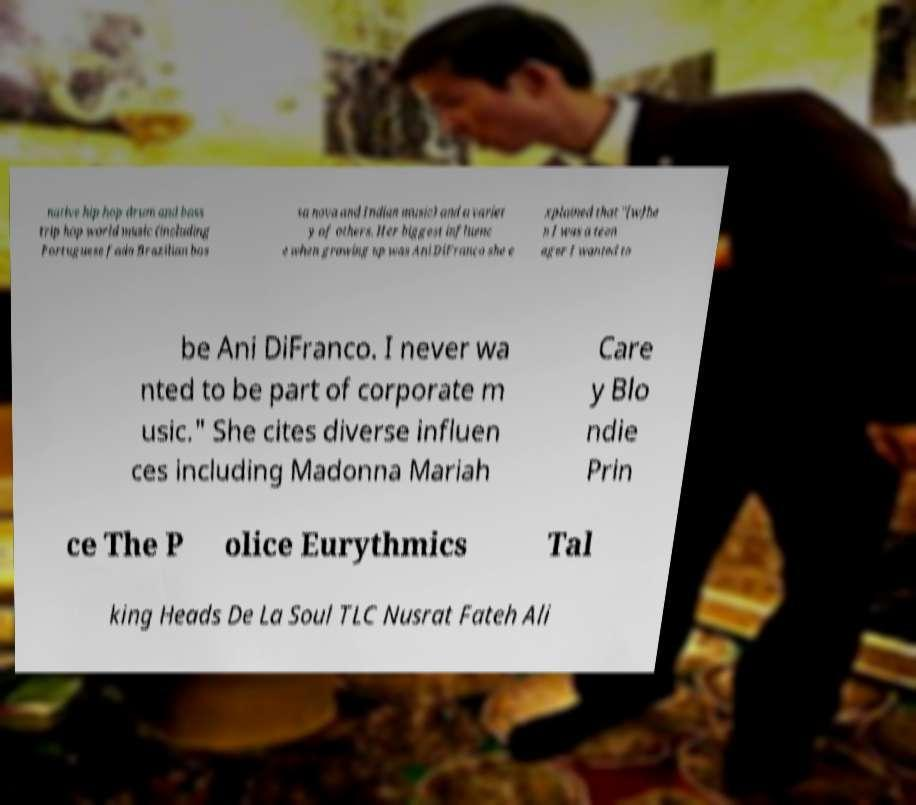Please read and relay the text visible in this image. What does it say? native hip hop drum and bass trip hop world music (including Portuguese fado Brazilian bos sa nova and Indian music) and a variet y of others. Her biggest influenc e when growing up was Ani DiFranco she e xplained that "[w]he n I was a teen ager I wanted to be Ani DiFranco. I never wa nted to be part of corporate m usic." She cites diverse influen ces including Madonna Mariah Care y Blo ndie Prin ce The P olice Eurythmics Tal king Heads De La Soul TLC Nusrat Fateh Ali 